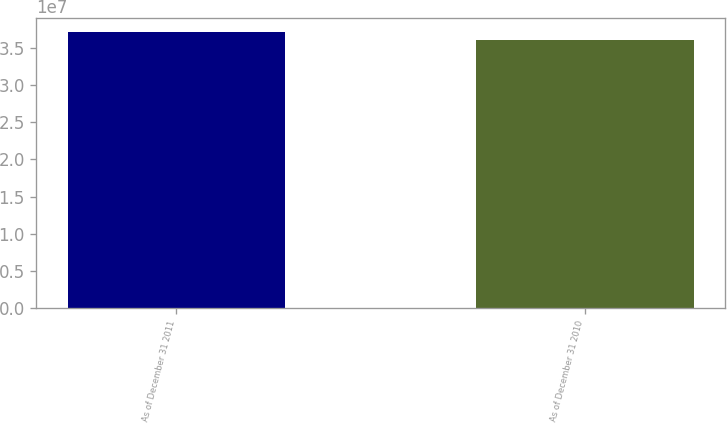Convert chart to OTSL. <chart><loc_0><loc_0><loc_500><loc_500><bar_chart><fcel>As of December 31 2011<fcel>As of December 31 2010<nl><fcel>3.71231e+07<fcel>3.61182e+07<nl></chart> 